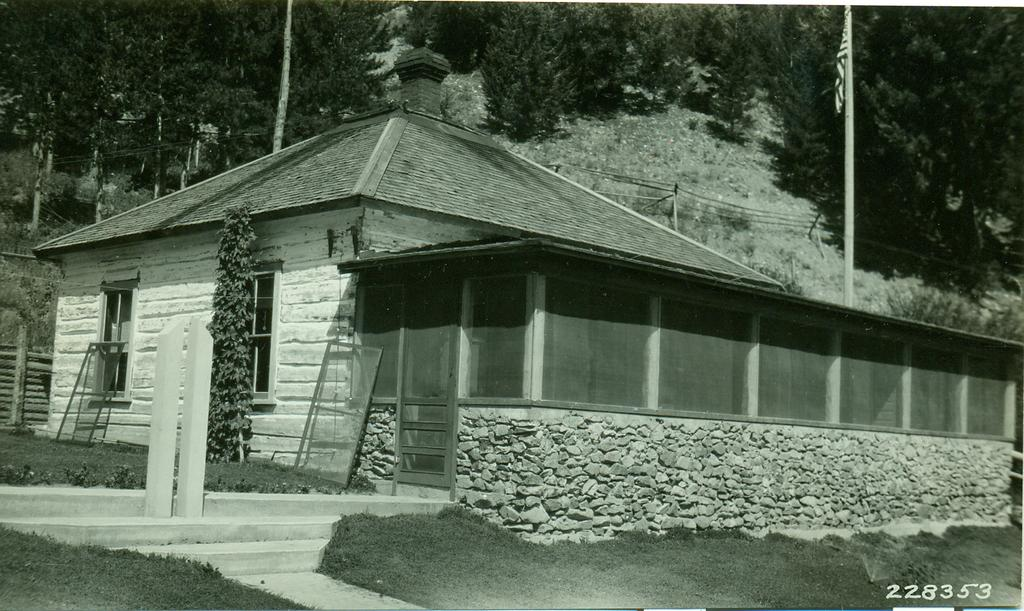What is located in the foreground of the image? There is a house in the foreground of the image, along with creepers and grass. What features can be seen on the house? There are windows on the house. What is visible in the background of the image? There are trees and a flagpole in the background of the image. Can you describe the time of day when the image was taken? The image was likely taken during the day, as there is sufficient light to see the details clearly. What level of the house is the front door located on? There is no information about a front door in the image, so it is impossible to determine its level. 